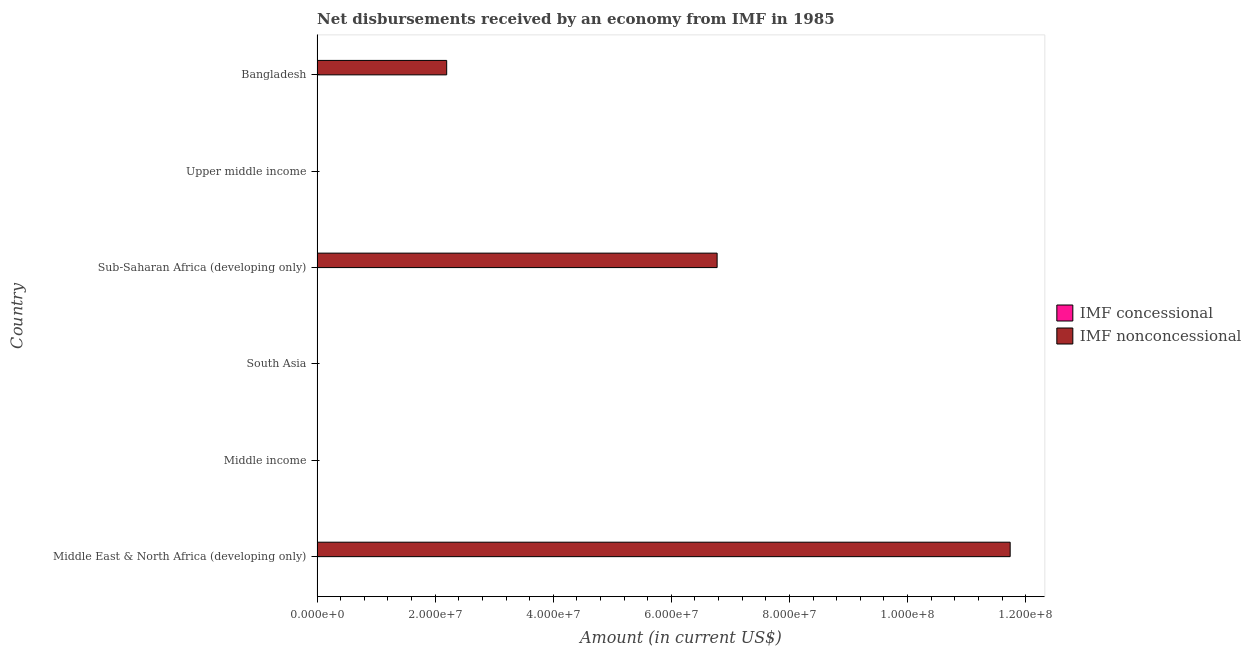How many bars are there on the 4th tick from the bottom?
Your answer should be compact. 1. What is the label of the 6th group of bars from the top?
Your answer should be compact. Middle East & North Africa (developing only). What is the net non concessional disbursements from imf in Middle East & North Africa (developing only)?
Keep it short and to the point. 1.17e+08. Across all countries, what is the maximum net non concessional disbursements from imf?
Your response must be concise. 1.17e+08. What is the total net non concessional disbursements from imf in the graph?
Provide a succinct answer. 2.07e+08. What is the difference between the net non concessional disbursements from imf in Middle East & North Africa (developing only) and that in Sub-Saharan Africa (developing only)?
Provide a short and direct response. 4.96e+07. What is the difference between the net concessional disbursements from imf in South Asia and the net non concessional disbursements from imf in Middle East & North Africa (developing only)?
Keep it short and to the point. -1.17e+08. In how many countries, is the net concessional disbursements from imf greater than 112000000 US$?
Offer a very short reply. 0. Is the net non concessional disbursements from imf in Middle East & North Africa (developing only) less than that in Sub-Saharan Africa (developing only)?
Keep it short and to the point. No. What is the difference between the highest and the second highest net non concessional disbursements from imf?
Make the answer very short. 4.96e+07. What is the difference between the highest and the lowest net non concessional disbursements from imf?
Your response must be concise. 1.17e+08. In how many countries, is the net concessional disbursements from imf greater than the average net concessional disbursements from imf taken over all countries?
Provide a short and direct response. 0. How many bars are there?
Your answer should be compact. 3. Are all the bars in the graph horizontal?
Your response must be concise. Yes. How many countries are there in the graph?
Provide a succinct answer. 6. What is the difference between two consecutive major ticks on the X-axis?
Your answer should be very brief. 2.00e+07. Does the graph contain any zero values?
Give a very brief answer. Yes. Where does the legend appear in the graph?
Your answer should be compact. Center right. What is the title of the graph?
Your answer should be compact. Net disbursements received by an economy from IMF in 1985. Does "Working capital" appear as one of the legend labels in the graph?
Your answer should be very brief. No. What is the label or title of the Y-axis?
Ensure brevity in your answer.  Country. What is the Amount (in current US$) in IMF concessional in Middle East & North Africa (developing only)?
Your answer should be compact. 0. What is the Amount (in current US$) in IMF nonconcessional in Middle East & North Africa (developing only)?
Your answer should be very brief. 1.17e+08. What is the Amount (in current US$) in IMF nonconcessional in South Asia?
Provide a short and direct response. 0. What is the Amount (in current US$) in IMF nonconcessional in Sub-Saharan Africa (developing only)?
Provide a short and direct response. 6.78e+07. What is the Amount (in current US$) in IMF nonconcessional in Upper middle income?
Ensure brevity in your answer.  0. What is the Amount (in current US$) of IMF concessional in Bangladesh?
Offer a very short reply. 0. What is the Amount (in current US$) of IMF nonconcessional in Bangladesh?
Make the answer very short. 2.20e+07. Across all countries, what is the maximum Amount (in current US$) of IMF nonconcessional?
Your response must be concise. 1.17e+08. Across all countries, what is the minimum Amount (in current US$) of IMF nonconcessional?
Provide a short and direct response. 0. What is the total Amount (in current US$) of IMF nonconcessional in the graph?
Ensure brevity in your answer.  2.07e+08. What is the difference between the Amount (in current US$) of IMF nonconcessional in Middle East & North Africa (developing only) and that in Sub-Saharan Africa (developing only)?
Keep it short and to the point. 4.96e+07. What is the difference between the Amount (in current US$) of IMF nonconcessional in Middle East & North Africa (developing only) and that in Bangladesh?
Provide a succinct answer. 9.54e+07. What is the difference between the Amount (in current US$) in IMF nonconcessional in Sub-Saharan Africa (developing only) and that in Bangladesh?
Ensure brevity in your answer.  4.58e+07. What is the average Amount (in current US$) of IMF concessional per country?
Make the answer very short. 0. What is the average Amount (in current US$) of IMF nonconcessional per country?
Give a very brief answer. 3.45e+07. What is the ratio of the Amount (in current US$) of IMF nonconcessional in Middle East & North Africa (developing only) to that in Sub-Saharan Africa (developing only)?
Your answer should be compact. 1.73. What is the ratio of the Amount (in current US$) in IMF nonconcessional in Middle East & North Africa (developing only) to that in Bangladesh?
Keep it short and to the point. 5.35. What is the ratio of the Amount (in current US$) in IMF nonconcessional in Sub-Saharan Africa (developing only) to that in Bangladesh?
Ensure brevity in your answer.  3.09. What is the difference between the highest and the second highest Amount (in current US$) in IMF nonconcessional?
Keep it short and to the point. 4.96e+07. What is the difference between the highest and the lowest Amount (in current US$) in IMF nonconcessional?
Offer a terse response. 1.17e+08. 